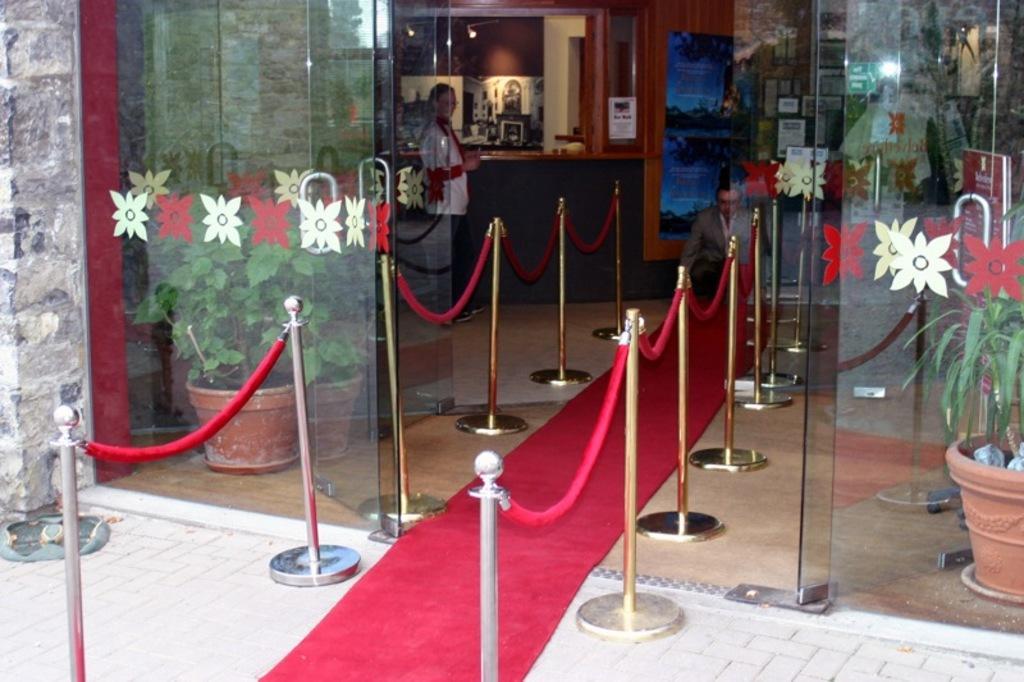How would you summarize this image in a sentence or two? Here I can see the glasses and poles are placed on the ground and also I can see a red color mat. In the inside few house plants are placed and in the background there is a table. I can see you few doors. There are two persons one person is sitting on the floor and one person is standing. 